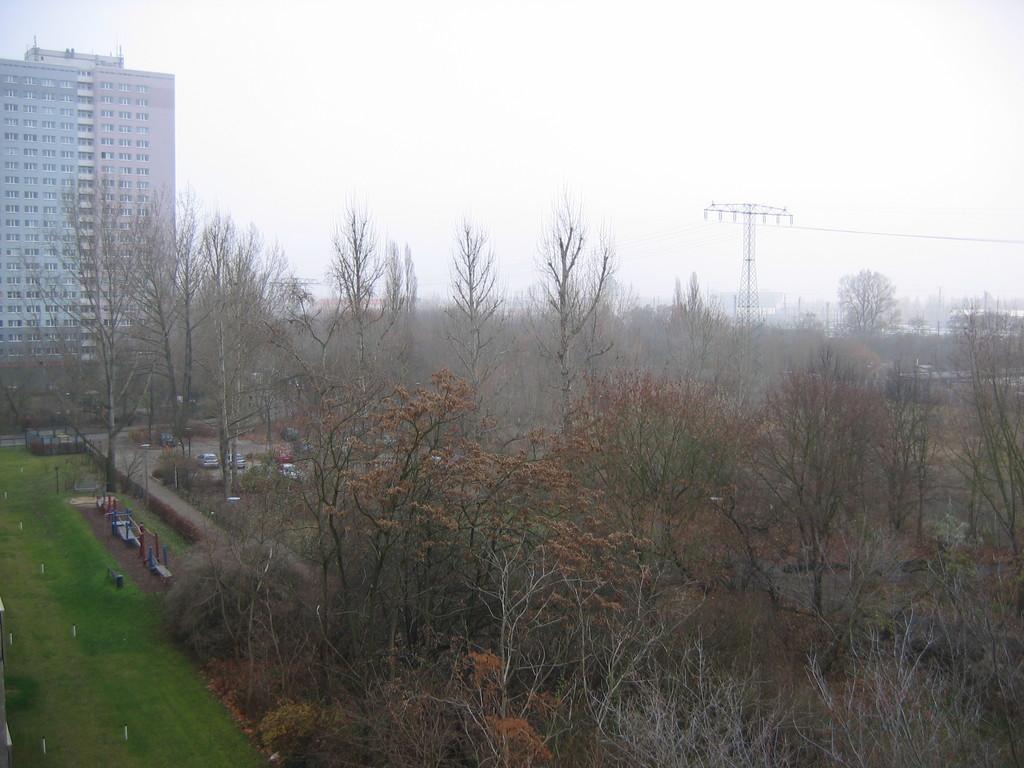Could you give a brief overview of what you see in this image? In this image I can see few dried trees and I can see the grass in green color. In the background I can see the tower and I can also see the building and the sky is white color. 